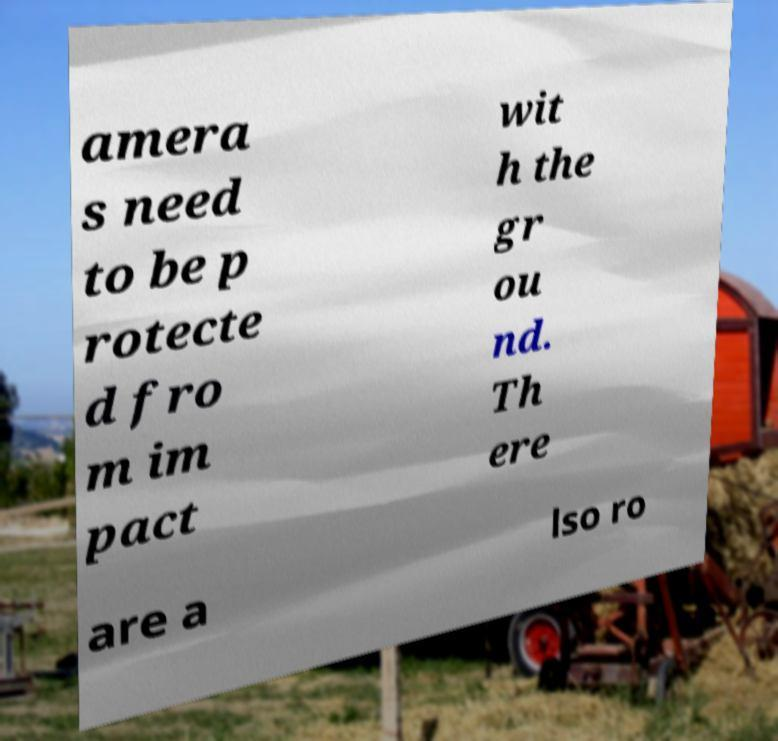There's text embedded in this image that I need extracted. Can you transcribe it verbatim? amera s need to be p rotecte d fro m im pact wit h the gr ou nd. Th ere are a lso ro 